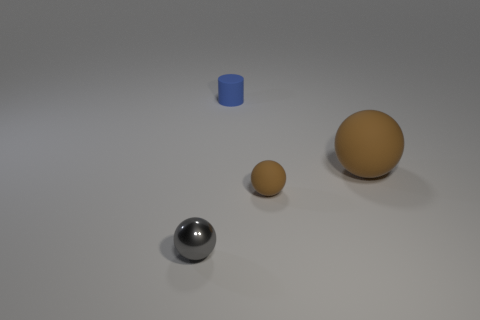Add 4 brown rubber things. How many objects exist? 8 Subtract all spheres. How many objects are left? 1 Subtract 0 cyan balls. How many objects are left? 4 Subtract all gray metallic objects. Subtract all tiny cylinders. How many objects are left? 2 Add 1 big brown things. How many big brown things are left? 2 Add 4 large green rubber cubes. How many large green rubber cubes exist? 4 